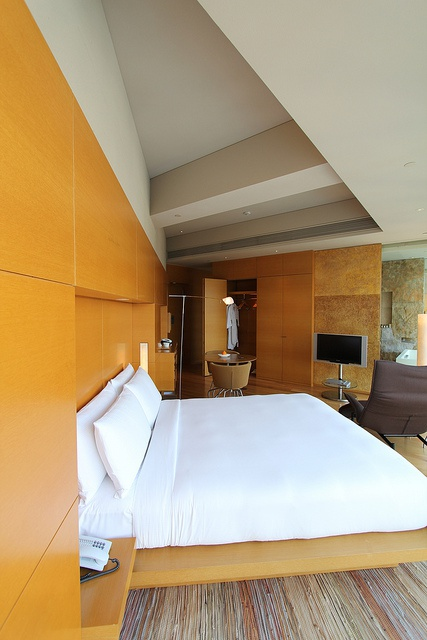Describe the objects in this image and their specific colors. I can see bed in orange, lavender, and tan tones, chair in orange, gray, and black tones, tv in orange, black, gray, and darkgray tones, chair in orange, maroon, and olive tones, and dining table in orange, maroon, brown, and black tones in this image. 